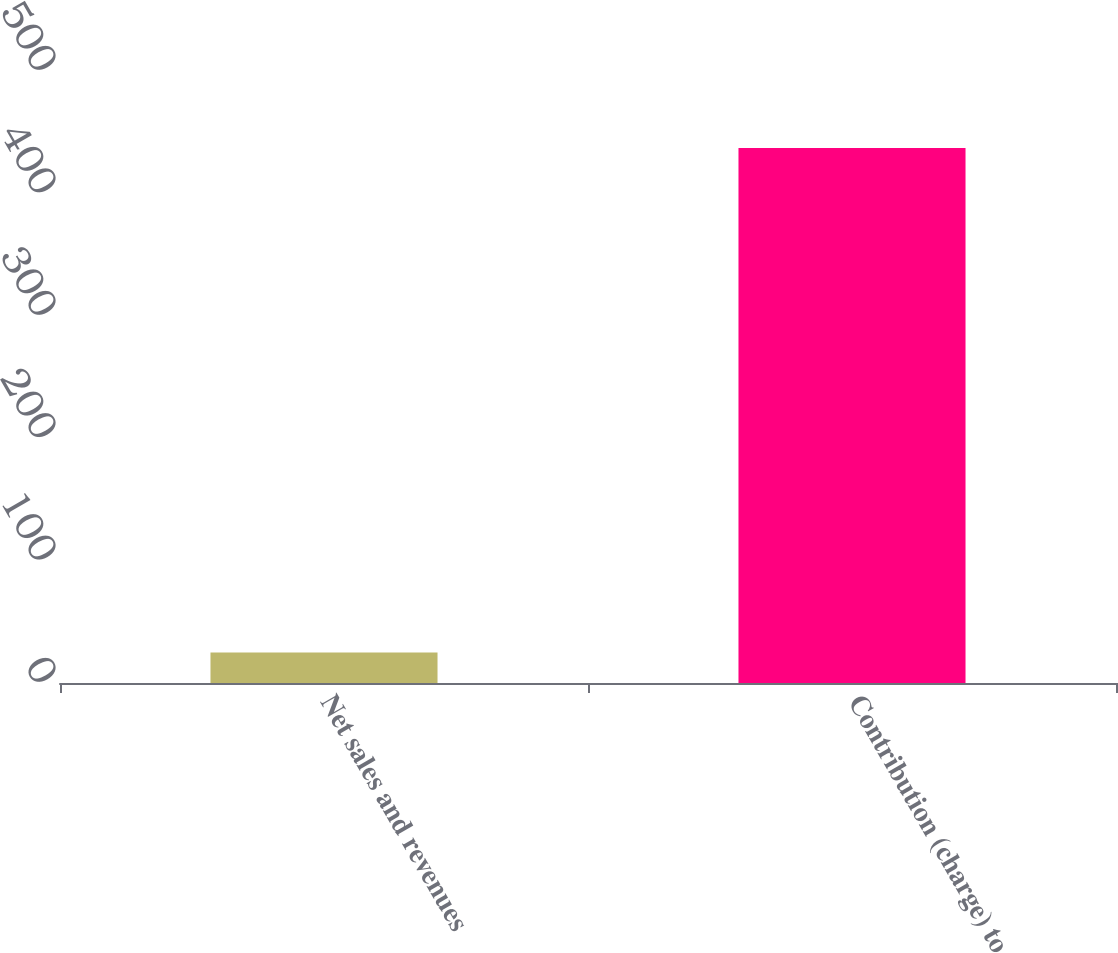Convert chart to OTSL. <chart><loc_0><loc_0><loc_500><loc_500><bar_chart><fcel>Net sales and revenues<fcel>Contribution (charge) to<nl><fcel>25<fcel>437<nl></chart> 